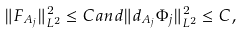<formula> <loc_0><loc_0><loc_500><loc_500>\| F _ { A _ { j } } \| _ { L ^ { 2 } } ^ { 2 } \leq C a n d \| d _ { A _ { j } } \Phi _ { j } \| _ { L ^ { 2 } } ^ { 2 } \leq C ,</formula> 